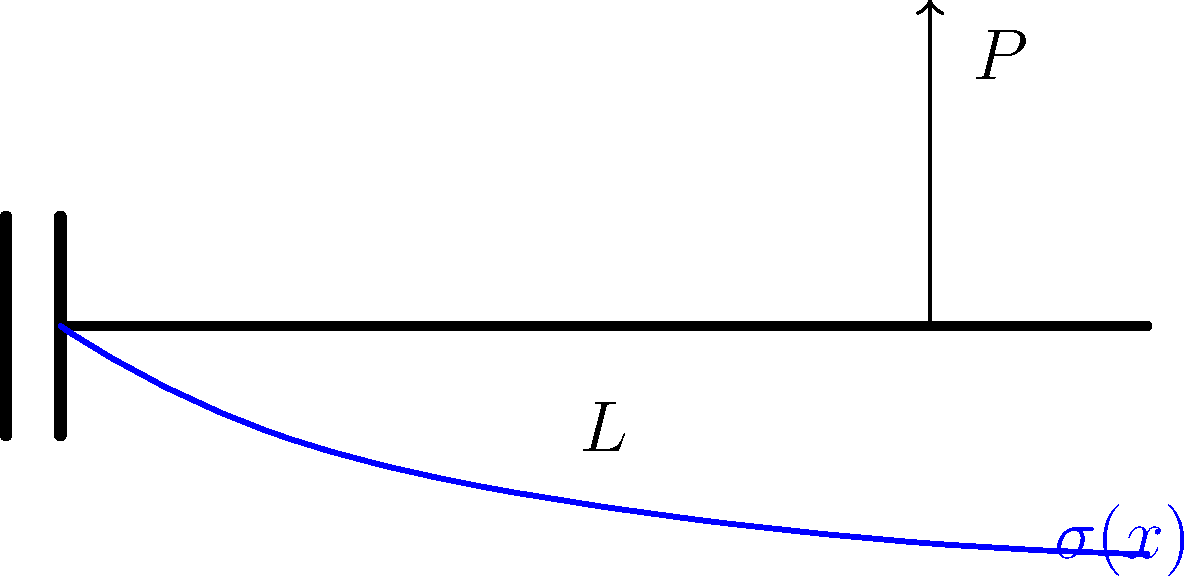In the context of cultural decision-making processes, consider a cantilever beam fixed at one end and subjected to a point load $P$ at its free end. How does the bending stress $\sigma(x)$ vary along the length of the beam, and what cultural factors might influence the interpretation of this stress distribution? To understand the stress distribution in a cantilever beam and its potential cultural implications, let's follow these steps:

1. Bending stress equation:
   The bending stress $\sigma(x)$ at any point along the beam is given by:
   $$\sigma(x) = \frac{M(x)y}{I}$$
   Where $M(x)$ is the bending moment, $y$ is the distance from the neutral axis, and $I$ is the moment of inertia.

2. Bending moment distribution:
   For a cantilever beam with a point load $P$ at the free end, the bending moment varies linearly:
   $$M(x) = P(L-x)$$
   Where $L$ is the length of the beam and $x$ is the distance from the fixed end.

3. Stress distribution:
   Substituting the bending moment into the stress equation:
   $$\sigma(x) = \frac{P(L-x)y}{I}$$
   This shows that the stress varies linearly along the length of the beam, with maximum stress at the fixed end $(x=0)$ and zero stress at the free end $(x=L)$.

4. Cultural interpretation:
   a) Risk perception: Different cultures may interpret the stress distribution as representing varying levels of risk or safety along the beam.
   b) Resource allocation: The stress distribution might influence how different cultures allocate resources for maintenance or reinforcement.
   c) Design philosophy: Some cultures may prefer designs that distribute stress more evenly, while others may accept localized high stress areas.
   d) Symbolic meaning: The shape of the stress distribution curve might hold different symbolic meanings in various cultural contexts.

5. Decision-making implications:
   a) Safety factors: Cultural attitudes towards risk may influence the choice of safety factors in engineering design.
   b) Material selection: Cultural preferences for certain materials may affect how stress distributions are managed.
   c) Aesthetics vs. function: The balance between visual appeal and structural efficiency may vary across cultures.
   d) Traditional vs. modern approaches: Some cultures may lean towards traditional building methods, while others may embrace modern stress analysis techniques.

Understanding the stress distribution in a cantilever beam through a cultural lens can provide insights into how different societies approach engineering challenges, risk assessment, and decision-making processes in structural design and urban planning.
Answer: Stress decreases linearly from fixed end to free end; cultural factors influence risk perception, resource allocation, design philosophy, and symbolic interpretation of stress distribution. 